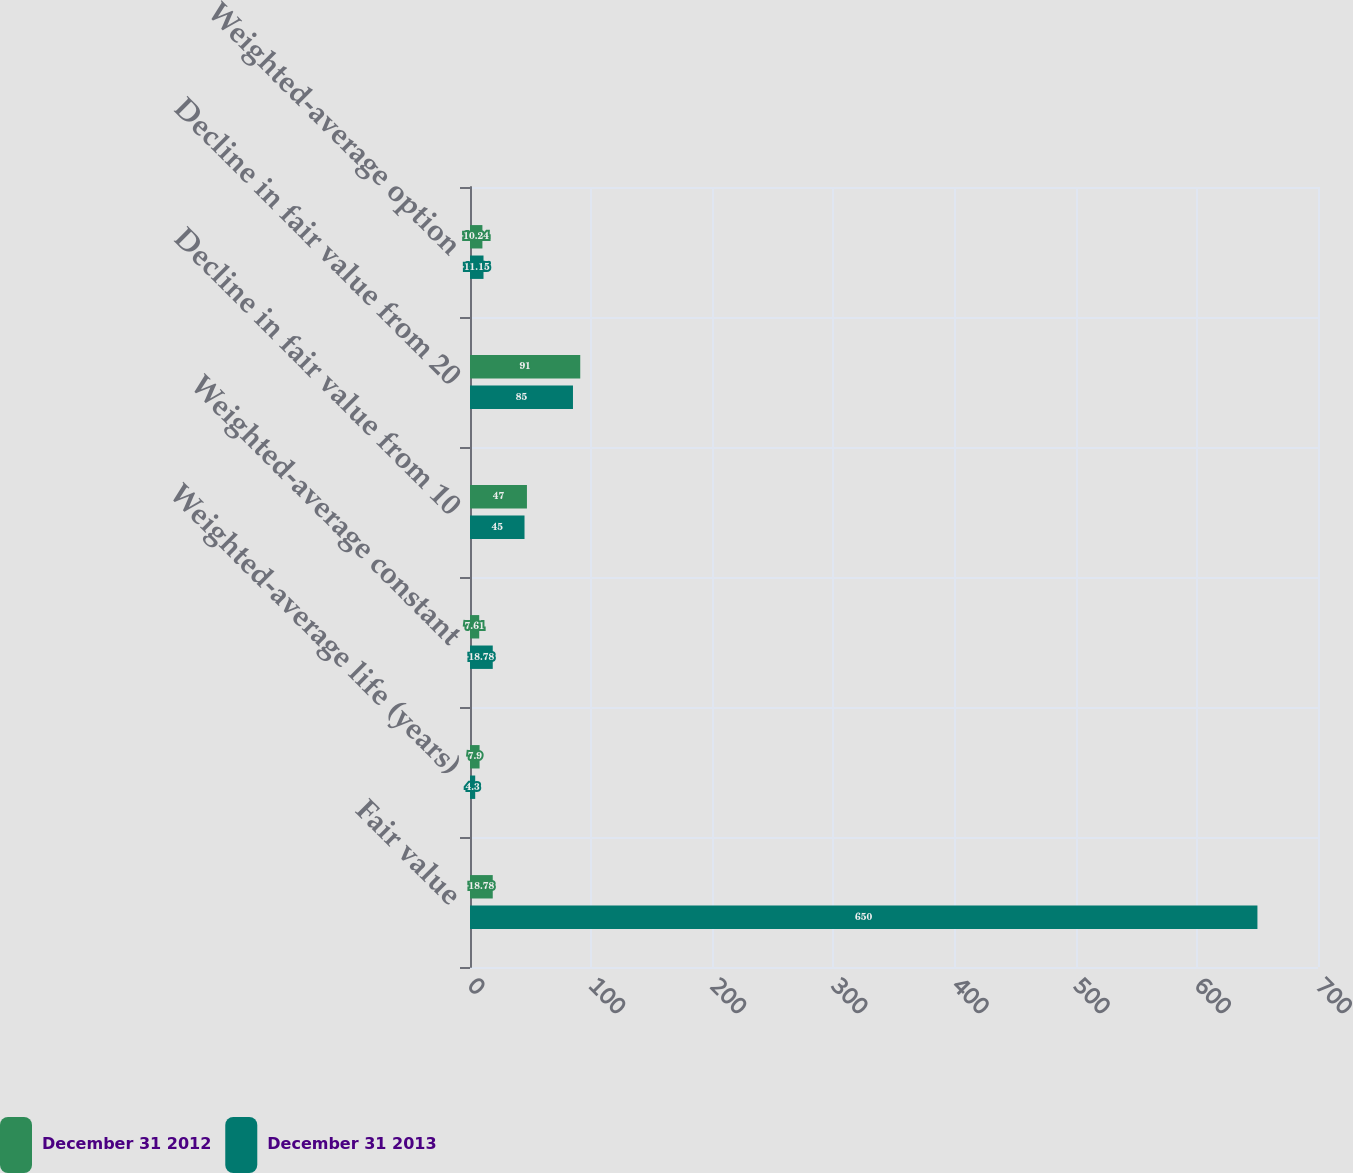Convert chart to OTSL. <chart><loc_0><loc_0><loc_500><loc_500><stacked_bar_chart><ecel><fcel>Fair value<fcel>Weighted-average life (years)<fcel>Weighted-average constant<fcel>Decline in fair value from 10<fcel>Decline in fair value from 20<fcel>Weighted-average option<nl><fcel>December 31 2012<fcel>18.78<fcel>7.9<fcel>7.61<fcel>47<fcel>91<fcel>10.24<nl><fcel>December 31 2013<fcel>650<fcel>4.3<fcel>18.78<fcel>45<fcel>85<fcel>11.15<nl></chart> 